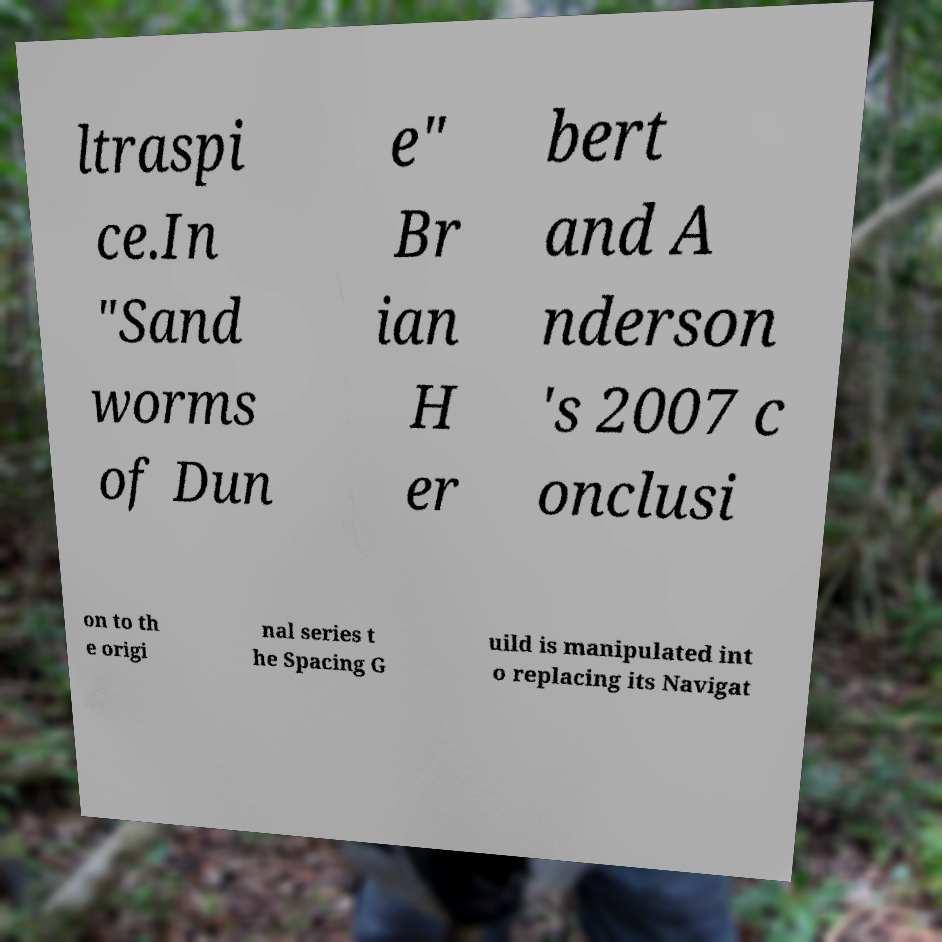Could you assist in decoding the text presented in this image and type it out clearly? ltraspi ce.In "Sand worms of Dun e" Br ian H er bert and A nderson 's 2007 c onclusi on to th e origi nal series t he Spacing G uild is manipulated int o replacing its Navigat 